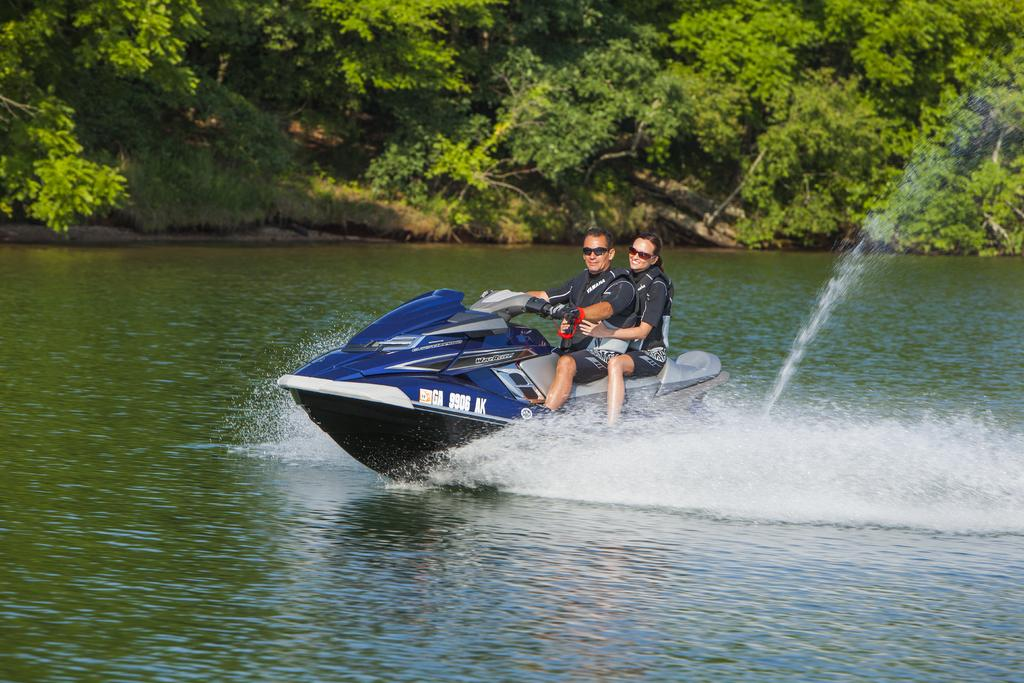How many people are in the image? There are two persons in the image. What are the persons doing in the image? The persons are sitting and riding a motor boat. Where is the motor boat located? The motor boat is on the water. What can be seen in the background of the image? There are trees in the background of the image. What type of light can be seen illuminating the motor boat in the image? There is no specific light source visible in the image that is illuminating the motor boat. 